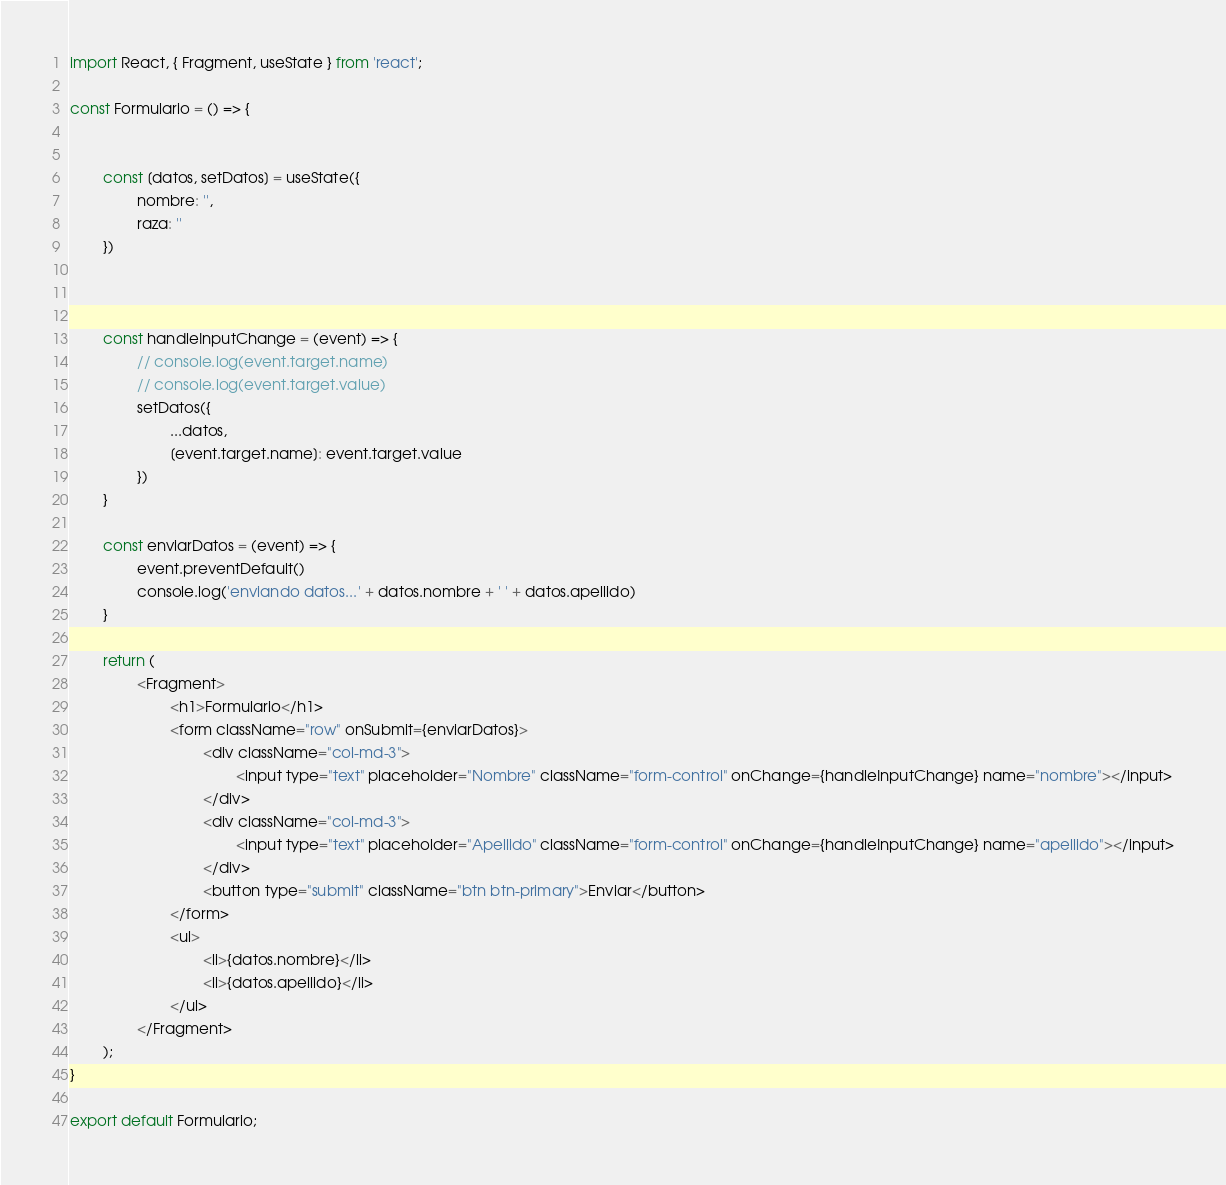Convert code to text. <code><loc_0><loc_0><loc_500><loc_500><_JavaScript_>import React, { Fragment, useState } from 'react';

const Formulario = () => {


        const [datos, setDatos] = useState({
                nombre: '',
                raza: ''
        })



        const handleInputChange = (event) => {
                // console.log(event.target.name)
                // console.log(event.target.value)
                setDatos({
                        ...datos,
                        [event.target.name]: event.target.value
                })
        }

        const enviarDatos = (event) => {
                event.preventDefault()
                console.log('enviando datos...' + datos.nombre + ' ' + datos.apellido)
        }

        return (
                <Fragment>
                        <h1>Formulario</h1>
                        <form className="row" onSubmit={enviarDatos}>
                                <div className="col-md-3">
                                        <input type="text" placeholder="Nombre" className="form-control" onChange={handleInputChange} name="nombre"></input>
                                </div>
                                <div className="col-md-3">
                                        <input type="text" placeholder="Apellido" className="form-control" onChange={handleInputChange} name="apellido"></input>
                                </div>
                                <button type="submit" className="btn btn-primary">Enviar</button>
                        </form>
                        <ul>
                                <li>{datos.nombre}</li>
                                <li>{datos.apellido}</li>
                        </ul>
                </Fragment>
        );
}

export default Formulario;</code> 